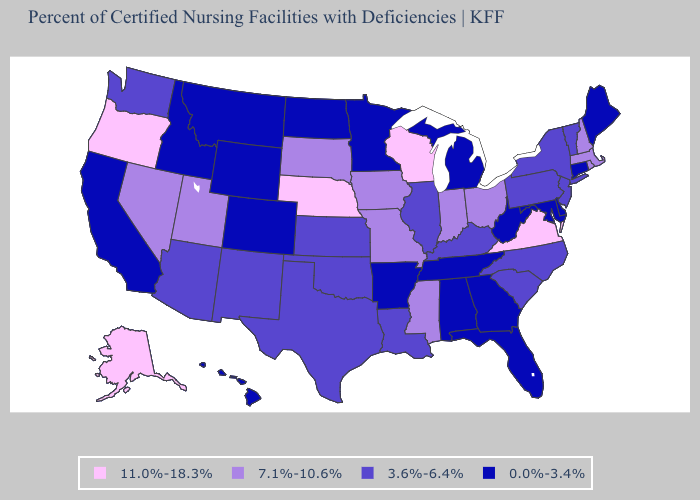What is the value of Illinois?
Give a very brief answer. 3.6%-6.4%. What is the lowest value in states that border Montana?
Quick response, please. 0.0%-3.4%. Which states hav the highest value in the West?
Be succinct. Alaska, Oregon. Name the states that have a value in the range 0.0%-3.4%?
Short answer required. Alabama, Arkansas, California, Colorado, Connecticut, Delaware, Florida, Georgia, Hawaii, Idaho, Maine, Maryland, Michigan, Minnesota, Montana, North Dakota, Tennessee, West Virginia, Wyoming. Does Utah have the highest value in the USA?
Short answer required. No. Does the map have missing data?
Answer briefly. No. Name the states that have a value in the range 11.0%-18.3%?
Answer briefly. Alaska, Nebraska, Oregon, Virginia, Wisconsin. Name the states that have a value in the range 3.6%-6.4%?
Keep it brief. Arizona, Illinois, Kansas, Kentucky, Louisiana, New Jersey, New Mexico, New York, North Carolina, Oklahoma, Pennsylvania, South Carolina, Texas, Vermont, Washington. Does Pennsylvania have the same value as Illinois?
Keep it brief. Yes. Which states hav the highest value in the Northeast?
Short answer required. Massachusetts, New Hampshire, Rhode Island. What is the lowest value in the MidWest?
Be succinct. 0.0%-3.4%. Name the states that have a value in the range 11.0%-18.3%?
Answer briefly. Alaska, Nebraska, Oregon, Virginia, Wisconsin. Name the states that have a value in the range 11.0%-18.3%?
Quick response, please. Alaska, Nebraska, Oregon, Virginia, Wisconsin. What is the value of North Dakota?
Short answer required. 0.0%-3.4%. What is the value of Kansas?
Short answer required. 3.6%-6.4%. 